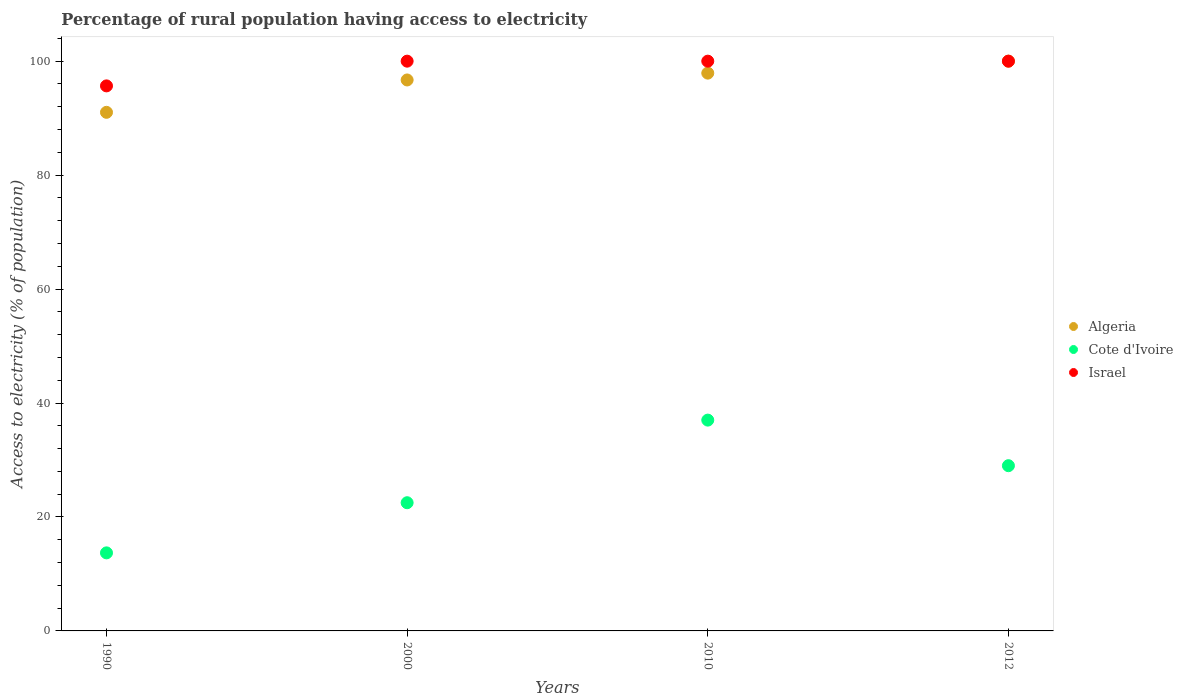Is the number of dotlines equal to the number of legend labels?
Provide a succinct answer. Yes. What is the percentage of rural population having access to electricity in Israel in 2010?
Offer a very short reply. 100. Across all years, what is the minimum percentage of rural population having access to electricity in Israel?
Offer a very short reply. 95.66. In which year was the percentage of rural population having access to electricity in Israel maximum?
Offer a terse response. 2000. What is the total percentage of rural population having access to electricity in Algeria in the graph?
Make the answer very short. 385.62. What is the difference between the percentage of rural population having access to electricity in Israel in 1990 and that in 2000?
Provide a short and direct response. -4.34. What is the difference between the percentage of rural population having access to electricity in Cote d'Ivoire in 1990 and the percentage of rural population having access to electricity in Israel in 2012?
Keep it short and to the point. -86.3. What is the average percentage of rural population having access to electricity in Cote d'Ivoire per year?
Offer a terse response. 25.55. In the year 2010, what is the difference between the percentage of rural population having access to electricity in Cote d'Ivoire and percentage of rural population having access to electricity in Israel?
Offer a very short reply. -63. In how many years, is the percentage of rural population having access to electricity in Cote d'Ivoire greater than 92 %?
Provide a succinct answer. 0. What is the ratio of the percentage of rural population having access to electricity in Cote d'Ivoire in 2000 to that in 2012?
Keep it short and to the point. 0.78. Is the difference between the percentage of rural population having access to electricity in Cote d'Ivoire in 2000 and 2012 greater than the difference between the percentage of rural population having access to electricity in Israel in 2000 and 2012?
Keep it short and to the point. No. What is the difference between the highest and the second highest percentage of rural population having access to electricity in Israel?
Provide a short and direct response. 0. What is the difference between the highest and the lowest percentage of rural population having access to electricity in Cote d'Ivoire?
Keep it short and to the point. 23.3. Is it the case that in every year, the sum of the percentage of rural population having access to electricity in Algeria and percentage of rural population having access to electricity in Israel  is greater than the percentage of rural population having access to electricity in Cote d'Ivoire?
Your response must be concise. Yes. Is the percentage of rural population having access to electricity in Cote d'Ivoire strictly greater than the percentage of rural population having access to electricity in Israel over the years?
Keep it short and to the point. No. Is the percentage of rural population having access to electricity in Israel strictly less than the percentage of rural population having access to electricity in Algeria over the years?
Offer a terse response. No. How many dotlines are there?
Give a very brief answer. 3. Where does the legend appear in the graph?
Your answer should be compact. Center right. How many legend labels are there?
Your answer should be very brief. 3. How are the legend labels stacked?
Offer a terse response. Vertical. What is the title of the graph?
Make the answer very short. Percentage of rural population having access to electricity. Does "Vietnam" appear as one of the legend labels in the graph?
Your answer should be compact. No. What is the label or title of the X-axis?
Give a very brief answer. Years. What is the label or title of the Y-axis?
Make the answer very short. Access to electricity (% of population). What is the Access to electricity (% of population) of Algeria in 1990?
Give a very brief answer. 91.02. What is the Access to electricity (% of population) of Cote d'Ivoire in 1990?
Keep it short and to the point. 13.7. What is the Access to electricity (% of population) in Israel in 1990?
Ensure brevity in your answer.  95.66. What is the Access to electricity (% of population) in Algeria in 2000?
Your response must be concise. 96.7. What is the Access to electricity (% of population) of Cote d'Ivoire in 2000?
Provide a short and direct response. 22.5. What is the Access to electricity (% of population) in Algeria in 2010?
Your answer should be compact. 97.9. What is the Access to electricity (% of population) in Cote d'Ivoire in 2010?
Provide a succinct answer. 37. What is the Access to electricity (% of population) of Israel in 2012?
Provide a succinct answer. 100. Across all years, what is the maximum Access to electricity (% of population) in Cote d'Ivoire?
Give a very brief answer. 37. Across all years, what is the maximum Access to electricity (% of population) in Israel?
Give a very brief answer. 100. Across all years, what is the minimum Access to electricity (% of population) in Algeria?
Offer a very short reply. 91.02. Across all years, what is the minimum Access to electricity (% of population) in Cote d'Ivoire?
Ensure brevity in your answer.  13.7. Across all years, what is the minimum Access to electricity (% of population) of Israel?
Provide a succinct answer. 95.66. What is the total Access to electricity (% of population) of Algeria in the graph?
Provide a short and direct response. 385.62. What is the total Access to electricity (% of population) of Cote d'Ivoire in the graph?
Your answer should be very brief. 102.2. What is the total Access to electricity (% of population) in Israel in the graph?
Offer a very short reply. 395.66. What is the difference between the Access to electricity (% of population) of Algeria in 1990 and that in 2000?
Your response must be concise. -5.68. What is the difference between the Access to electricity (% of population) in Cote d'Ivoire in 1990 and that in 2000?
Offer a very short reply. -8.8. What is the difference between the Access to electricity (% of population) in Israel in 1990 and that in 2000?
Offer a very short reply. -4.34. What is the difference between the Access to electricity (% of population) of Algeria in 1990 and that in 2010?
Make the answer very short. -6.88. What is the difference between the Access to electricity (% of population) of Cote d'Ivoire in 1990 and that in 2010?
Your response must be concise. -23.3. What is the difference between the Access to electricity (% of population) of Israel in 1990 and that in 2010?
Provide a short and direct response. -4.34. What is the difference between the Access to electricity (% of population) of Algeria in 1990 and that in 2012?
Keep it short and to the point. -8.98. What is the difference between the Access to electricity (% of population) in Cote d'Ivoire in 1990 and that in 2012?
Provide a succinct answer. -15.3. What is the difference between the Access to electricity (% of population) in Israel in 1990 and that in 2012?
Provide a succinct answer. -4.34. What is the difference between the Access to electricity (% of population) of Cote d'Ivoire in 2000 and that in 2010?
Your response must be concise. -14.5. What is the difference between the Access to electricity (% of population) of Israel in 2000 and that in 2010?
Give a very brief answer. 0. What is the difference between the Access to electricity (% of population) of Algeria in 2000 and that in 2012?
Ensure brevity in your answer.  -3.3. What is the difference between the Access to electricity (% of population) in Israel in 2000 and that in 2012?
Provide a short and direct response. 0. What is the difference between the Access to electricity (% of population) in Algeria in 2010 and that in 2012?
Make the answer very short. -2.1. What is the difference between the Access to electricity (% of population) of Cote d'Ivoire in 2010 and that in 2012?
Make the answer very short. 8. What is the difference between the Access to electricity (% of population) of Israel in 2010 and that in 2012?
Provide a short and direct response. 0. What is the difference between the Access to electricity (% of population) in Algeria in 1990 and the Access to electricity (% of population) in Cote d'Ivoire in 2000?
Your response must be concise. 68.52. What is the difference between the Access to electricity (% of population) in Algeria in 1990 and the Access to electricity (% of population) in Israel in 2000?
Keep it short and to the point. -8.98. What is the difference between the Access to electricity (% of population) of Cote d'Ivoire in 1990 and the Access to electricity (% of population) of Israel in 2000?
Ensure brevity in your answer.  -86.3. What is the difference between the Access to electricity (% of population) of Algeria in 1990 and the Access to electricity (% of population) of Cote d'Ivoire in 2010?
Make the answer very short. 54.02. What is the difference between the Access to electricity (% of population) of Algeria in 1990 and the Access to electricity (% of population) of Israel in 2010?
Make the answer very short. -8.98. What is the difference between the Access to electricity (% of population) in Cote d'Ivoire in 1990 and the Access to electricity (% of population) in Israel in 2010?
Your response must be concise. -86.3. What is the difference between the Access to electricity (% of population) of Algeria in 1990 and the Access to electricity (% of population) of Cote d'Ivoire in 2012?
Keep it short and to the point. 62.02. What is the difference between the Access to electricity (% of population) of Algeria in 1990 and the Access to electricity (% of population) of Israel in 2012?
Your response must be concise. -8.98. What is the difference between the Access to electricity (% of population) of Cote d'Ivoire in 1990 and the Access to electricity (% of population) of Israel in 2012?
Give a very brief answer. -86.3. What is the difference between the Access to electricity (% of population) of Algeria in 2000 and the Access to electricity (% of population) of Cote d'Ivoire in 2010?
Your answer should be compact. 59.7. What is the difference between the Access to electricity (% of population) in Algeria in 2000 and the Access to electricity (% of population) in Israel in 2010?
Your answer should be very brief. -3.3. What is the difference between the Access to electricity (% of population) in Cote d'Ivoire in 2000 and the Access to electricity (% of population) in Israel in 2010?
Your response must be concise. -77.5. What is the difference between the Access to electricity (% of population) in Algeria in 2000 and the Access to electricity (% of population) in Cote d'Ivoire in 2012?
Provide a succinct answer. 67.7. What is the difference between the Access to electricity (% of population) in Cote d'Ivoire in 2000 and the Access to electricity (% of population) in Israel in 2012?
Your answer should be very brief. -77.5. What is the difference between the Access to electricity (% of population) of Algeria in 2010 and the Access to electricity (% of population) of Cote d'Ivoire in 2012?
Your answer should be very brief. 68.9. What is the difference between the Access to electricity (% of population) of Cote d'Ivoire in 2010 and the Access to electricity (% of population) of Israel in 2012?
Provide a short and direct response. -63. What is the average Access to electricity (% of population) in Algeria per year?
Your answer should be very brief. 96.4. What is the average Access to electricity (% of population) in Cote d'Ivoire per year?
Ensure brevity in your answer.  25.55. What is the average Access to electricity (% of population) of Israel per year?
Ensure brevity in your answer.  98.92. In the year 1990, what is the difference between the Access to electricity (% of population) in Algeria and Access to electricity (% of population) in Cote d'Ivoire?
Offer a terse response. 77.32. In the year 1990, what is the difference between the Access to electricity (% of population) in Algeria and Access to electricity (% of population) in Israel?
Ensure brevity in your answer.  -4.64. In the year 1990, what is the difference between the Access to electricity (% of population) in Cote d'Ivoire and Access to electricity (% of population) in Israel?
Make the answer very short. -81.96. In the year 2000, what is the difference between the Access to electricity (% of population) of Algeria and Access to electricity (% of population) of Cote d'Ivoire?
Your answer should be very brief. 74.2. In the year 2000, what is the difference between the Access to electricity (% of population) of Algeria and Access to electricity (% of population) of Israel?
Your answer should be compact. -3.3. In the year 2000, what is the difference between the Access to electricity (% of population) in Cote d'Ivoire and Access to electricity (% of population) in Israel?
Keep it short and to the point. -77.5. In the year 2010, what is the difference between the Access to electricity (% of population) of Algeria and Access to electricity (% of population) of Cote d'Ivoire?
Offer a very short reply. 60.9. In the year 2010, what is the difference between the Access to electricity (% of population) of Algeria and Access to electricity (% of population) of Israel?
Keep it short and to the point. -2.1. In the year 2010, what is the difference between the Access to electricity (% of population) of Cote d'Ivoire and Access to electricity (% of population) of Israel?
Offer a terse response. -63. In the year 2012, what is the difference between the Access to electricity (% of population) of Cote d'Ivoire and Access to electricity (% of population) of Israel?
Keep it short and to the point. -71. What is the ratio of the Access to electricity (% of population) of Algeria in 1990 to that in 2000?
Give a very brief answer. 0.94. What is the ratio of the Access to electricity (% of population) in Cote d'Ivoire in 1990 to that in 2000?
Your answer should be very brief. 0.61. What is the ratio of the Access to electricity (% of population) of Israel in 1990 to that in 2000?
Give a very brief answer. 0.96. What is the ratio of the Access to electricity (% of population) in Algeria in 1990 to that in 2010?
Ensure brevity in your answer.  0.93. What is the ratio of the Access to electricity (% of population) of Cote d'Ivoire in 1990 to that in 2010?
Give a very brief answer. 0.37. What is the ratio of the Access to electricity (% of population) of Israel in 1990 to that in 2010?
Provide a short and direct response. 0.96. What is the ratio of the Access to electricity (% of population) of Algeria in 1990 to that in 2012?
Provide a succinct answer. 0.91. What is the ratio of the Access to electricity (% of population) in Cote d'Ivoire in 1990 to that in 2012?
Keep it short and to the point. 0.47. What is the ratio of the Access to electricity (% of population) in Israel in 1990 to that in 2012?
Your answer should be very brief. 0.96. What is the ratio of the Access to electricity (% of population) of Cote d'Ivoire in 2000 to that in 2010?
Provide a short and direct response. 0.61. What is the ratio of the Access to electricity (% of population) in Cote d'Ivoire in 2000 to that in 2012?
Ensure brevity in your answer.  0.78. What is the ratio of the Access to electricity (% of population) in Israel in 2000 to that in 2012?
Provide a succinct answer. 1. What is the ratio of the Access to electricity (% of population) of Cote d'Ivoire in 2010 to that in 2012?
Your answer should be very brief. 1.28. What is the difference between the highest and the second highest Access to electricity (% of population) of Israel?
Offer a very short reply. 0. What is the difference between the highest and the lowest Access to electricity (% of population) in Algeria?
Offer a terse response. 8.98. What is the difference between the highest and the lowest Access to electricity (% of population) of Cote d'Ivoire?
Offer a very short reply. 23.3. What is the difference between the highest and the lowest Access to electricity (% of population) of Israel?
Your answer should be compact. 4.34. 